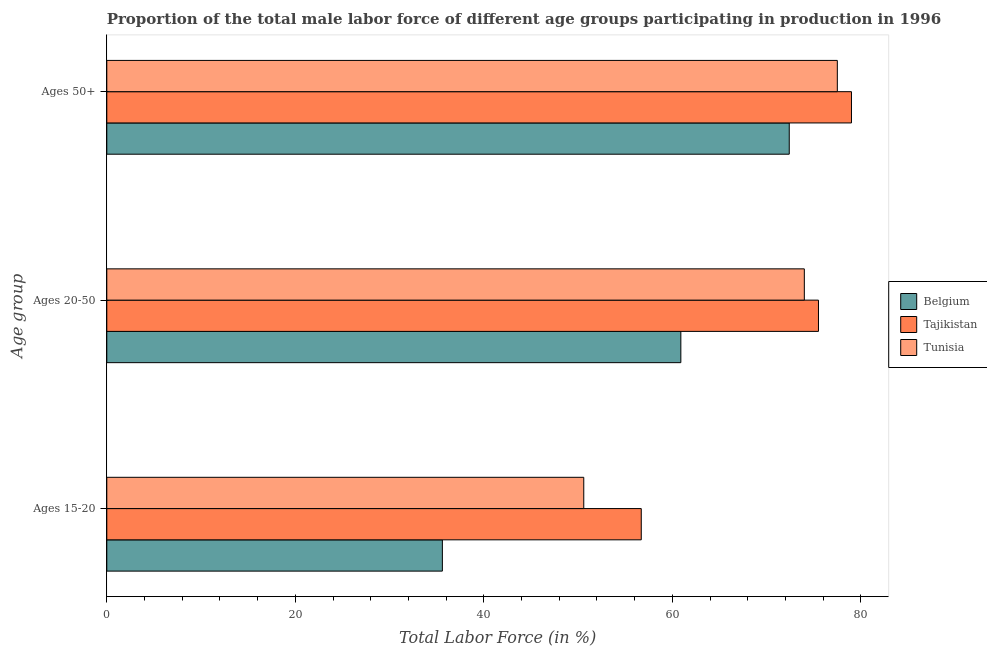How many different coloured bars are there?
Make the answer very short. 3. Are the number of bars per tick equal to the number of legend labels?
Give a very brief answer. Yes. Are the number of bars on each tick of the Y-axis equal?
Ensure brevity in your answer.  Yes. How many bars are there on the 1st tick from the top?
Keep it short and to the point. 3. How many bars are there on the 1st tick from the bottom?
Offer a very short reply. 3. What is the label of the 2nd group of bars from the top?
Provide a short and direct response. Ages 20-50. What is the percentage of male labor force within the age group 15-20 in Tajikistan?
Provide a short and direct response. 56.7. Across all countries, what is the maximum percentage of male labor force above age 50?
Give a very brief answer. 79. Across all countries, what is the minimum percentage of male labor force above age 50?
Provide a succinct answer. 72.4. In which country was the percentage of male labor force above age 50 maximum?
Your answer should be very brief. Tajikistan. In which country was the percentage of male labor force within the age group 15-20 minimum?
Provide a short and direct response. Belgium. What is the total percentage of male labor force above age 50 in the graph?
Offer a very short reply. 228.9. What is the difference between the percentage of male labor force within the age group 20-50 in Belgium and that in Tajikistan?
Offer a very short reply. -14.6. What is the difference between the percentage of male labor force within the age group 15-20 in Belgium and the percentage of male labor force within the age group 20-50 in Tunisia?
Keep it short and to the point. -38.4. What is the average percentage of male labor force within the age group 15-20 per country?
Your response must be concise. 47.63. What is the difference between the percentage of male labor force within the age group 20-50 and percentage of male labor force within the age group 15-20 in Tajikistan?
Keep it short and to the point. 18.8. What is the ratio of the percentage of male labor force within the age group 20-50 in Tunisia to that in Belgium?
Provide a succinct answer. 1.22. Is the percentage of male labor force above age 50 in Tajikistan less than that in Tunisia?
Provide a succinct answer. No. What is the difference between the highest and the second highest percentage of male labor force within the age group 15-20?
Offer a very short reply. 6.1. What is the difference between the highest and the lowest percentage of male labor force above age 50?
Keep it short and to the point. 6.6. In how many countries, is the percentage of male labor force within the age group 15-20 greater than the average percentage of male labor force within the age group 15-20 taken over all countries?
Your answer should be compact. 2. What does the 3rd bar from the bottom in Ages 50+ represents?
Your answer should be compact. Tunisia. Is it the case that in every country, the sum of the percentage of male labor force within the age group 15-20 and percentage of male labor force within the age group 20-50 is greater than the percentage of male labor force above age 50?
Keep it short and to the point. Yes. Does the graph contain any zero values?
Ensure brevity in your answer.  No. Where does the legend appear in the graph?
Provide a short and direct response. Center right. How many legend labels are there?
Offer a terse response. 3. How are the legend labels stacked?
Offer a terse response. Vertical. What is the title of the graph?
Give a very brief answer. Proportion of the total male labor force of different age groups participating in production in 1996. Does "Lower middle income" appear as one of the legend labels in the graph?
Offer a very short reply. No. What is the label or title of the Y-axis?
Make the answer very short. Age group. What is the Total Labor Force (in %) in Belgium in Ages 15-20?
Make the answer very short. 35.6. What is the Total Labor Force (in %) of Tajikistan in Ages 15-20?
Your response must be concise. 56.7. What is the Total Labor Force (in %) of Tunisia in Ages 15-20?
Offer a very short reply. 50.6. What is the Total Labor Force (in %) of Belgium in Ages 20-50?
Provide a succinct answer. 60.9. What is the Total Labor Force (in %) of Tajikistan in Ages 20-50?
Offer a terse response. 75.5. What is the Total Labor Force (in %) in Belgium in Ages 50+?
Give a very brief answer. 72.4. What is the Total Labor Force (in %) of Tajikistan in Ages 50+?
Provide a succinct answer. 79. What is the Total Labor Force (in %) in Tunisia in Ages 50+?
Your answer should be compact. 77.5. Across all Age group, what is the maximum Total Labor Force (in %) of Belgium?
Your response must be concise. 72.4. Across all Age group, what is the maximum Total Labor Force (in %) of Tajikistan?
Your answer should be compact. 79. Across all Age group, what is the maximum Total Labor Force (in %) in Tunisia?
Provide a short and direct response. 77.5. Across all Age group, what is the minimum Total Labor Force (in %) of Belgium?
Your answer should be compact. 35.6. Across all Age group, what is the minimum Total Labor Force (in %) of Tajikistan?
Make the answer very short. 56.7. Across all Age group, what is the minimum Total Labor Force (in %) in Tunisia?
Offer a terse response. 50.6. What is the total Total Labor Force (in %) of Belgium in the graph?
Provide a succinct answer. 168.9. What is the total Total Labor Force (in %) of Tajikistan in the graph?
Give a very brief answer. 211.2. What is the total Total Labor Force (in %) in Tunisia in the graph?
Make the answer very short. 202.1. What is the difference between the Total Labor Force (in %) in Belgium in Ages 15-20 and that in Ages 20-50?
Provide a short and direct response. -25.3. What is the difference between the Total Labor Force (in %) in Tajikistan in Ages 15-20 and that in Ages 20-50?
Provide a succinct answer. -18.8. What is the difference between the Total Labor Force (in %) in Tunisia in Ages 15-20 and that in Ages 20-50?
Offer a very short reply. -23.4. What is the difference between the Total Labor Force (in %) in Belgium in Ages 15-20 and that in Ages 50+?
Offer a terse response. -36.8. What is the difference between the Total Labor Force (in %) in Tajikistan in Ages 15-20 and that in Ages 50+?
Make the answer very short. -22.3. What is the difference between the Total Labor Force (in %) of Tunisia in Ages 15-20 and that in Ages 50+?
Provide a short and direct response. -26.9. What is the difference between the Total Labor Force (in %) in Tajikistan in Ages 20-50 and that in Ages 50+?
Offer a very short reply. -3.5. What is the difference between the Total Labor Force (in %) in Belgium in Ages 15-20 and the Total Labor Force (in %) in Tajikistan in Ages 20-50?
Give a very brief answer. -39.9. What is the difference between the Total Labor Force (in %) of Belgium in Ages 15-20 and the Total Labor Force (in %) of Tunisia in Ages 20-50?
Keep it short and to the point. -38.4. What is the difference between the Total Labor Force (in %) in Tajikistan in Ages 15-20 and the Total Labor Force (in %) in Tunisia in Ages 20-50?
Ensure brevity in your answer.  -17.3. What is the difference between the Total Labor Force (in %) in Belgium in Ages 15-20 and the Total Labor Force (in %) in Tajikistan in Ages 50+?
Keep it short and to the point. -43.4. What is the difference between the Total Labor Force (in %) in Belgium in Ages 15-20 and the Total Labor Force (in %) in Tunisia in Ages 50+?
Ensure brevity in your answer.  -41.9. What is the difference between the Total Labor Force (in %) of Tajikistan in Ages 15-20 and the Total Labor Force (in %) of Tunisia in Ages 50+?
Offer a terse response. -20.8. What is the difference between the Total Labor Force (in %) in Belgium in Ages 20-50 and the Total Labor Force (in %) in Tajikistan in Ages 50+?
Keep it short and to the point. -18.1. What is the difference between the Total Labor Force (in %) in Belgium in Ages 20-50 and the Total Labor Force (in %) in Tunisia in Ages 50+?
Make the answer very short. -16.6. What is the average Total Labor Force (in %) in Belgium per Age group?
Provide a succinct answer. 56.3. What is the average Total Labor Force (in %) of Tajikistan per Age group?
Offer a terse response. 70.4. What is the average Total Labor Force (in %) in Tunisia per Age group?
Your answer should be compact. 67.37. What is the difference between the Total Labor Force (in %) in Belgium and Total Labor Force (in %) in Tajikistan in Ages 15-20?
Ensure brevity in your answer.  -21.1. What is the difference between the Total Labor Force (in %) in Belgium and Total Labor Force (in %) in Tunisia in Ages 15-20?
Make the answer very short. -15. What is the difference between the Total Labor Force (in %) of Belgium and Total Labor Force (in %) of Tajikistan in Ages 20-50?
Your answer should be compact. -14.6. What is the difference between the Total Labor Force (in %) in Belgium and Total Labor Force (in %) in Tunisia in Ages 50+?
Offer a terse response. -5.1. What is the difference between the Total Labor Force (in %) in Tajikistan and Total Labor Force (in %) in Tunisia in Ages 50+?
Ensure brevity in your answer.  1.5. What is the ratio of the Total Labor Force (in %) in Belgium in Ages 15-20 to that in Ages 20-50?
Offer a very short reply. 0.58. What is the ratio of the Total Labor Force (in %) in Tajikistan in Ages 15-20 to that in Ages 20-50?
Offer a very short reply. 0.75. What is the ratio of the Total Labor Force (in %) in Tunisia in Ages 15-20 to that in Ages 20-50?
Your answer should be compact. 0.68. What is the ratio of the Total Labor Force (in %) of Belgium in Ages 15-20 to that in Ages 50+?
Make the answer very short. 0.49. What is the ratio of the Total Labor Force (in %) in Tajikistan in Ages 15-20 to that in Ages 50+?
Provide a short and direct response. 0.72. What is the ratio of the Total Labor Force (in %) of Tunisia in Ages 15-20 to that in Ages 50+?
Your answer should be very brief. 0.65. What is the ratio of the Total Labor Force (in %) of Belgium in Ages 20-50 to that in Ages 50+?
Your answer should be very brief. 0.84. What is the ratio of the Total Labor Force (in %) of Tajikistan in Ages 20-50 to that in Ages 50+?
Your answer should be very brief. 0.96. What is the ratio of the Total Labor Force (in %) of Tunisia in Ages 20-50 to that in Ages 50+?
Your answer should be compact. 0.95. What is the difference between the highest and the second highest Total Labor Force (in %) in Belgium?
Offer a very short reply. 11.5. What is the difference between the highest and the second highest Total Labor Force (in %) in Tajikistan?
Offer a very short reply. 3.5. What is the difference between the highest and the lowest Total Labor Force (in %) of Belgium?
Provide a succinct answer. 36.8. What is the difference between the highest and the lowest Total Labor Force (in %) in Tajikistan?
Provide a short and direct response. 22.3. What is the difference between the highest and the lowest Total Labor Force (in %) of Tunisia?
Keep it short and to the point. 26.9. 